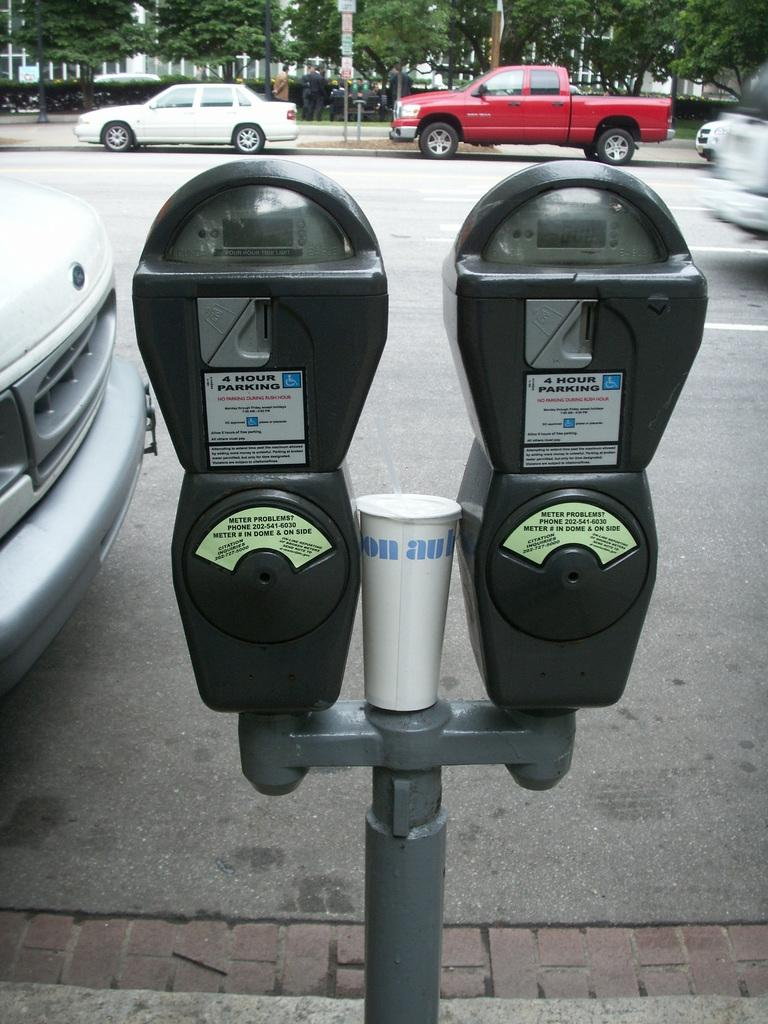<image>
Write a terse but informative summary of the picture. A pair of 4 hour parking meters with paper cup propped between them. 